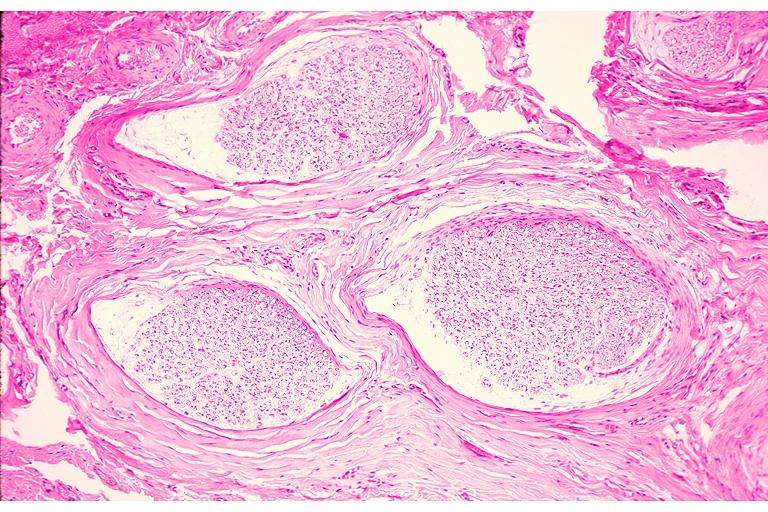does this image show traumatic neuroma?
Answer the question using a single word or phrase. Yes 